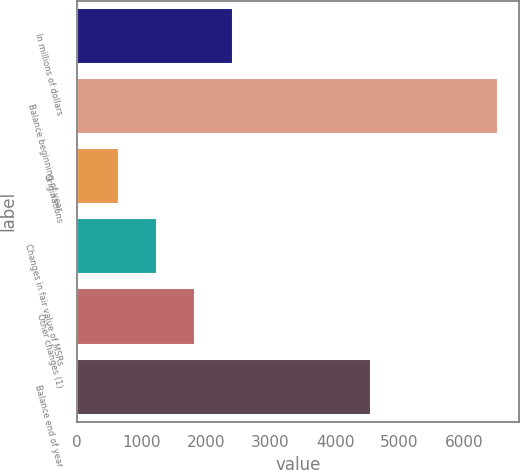Convert chart to OTSL. <chart><loc_0><loc_0><loc_500><loc_500><bar_chart><fcel>In millions of dollars<fcel>Balance beginning of year<fcel>Originations<fcel>Changes in fair value of MSRs<fcel>Other changes (1)<fcel>Balance end of year<nl><fcel>2419.6<fcel>6530<fcel>658<fcel>1245.2<fcel>1832.4<fcel>4554<nl></chart> 